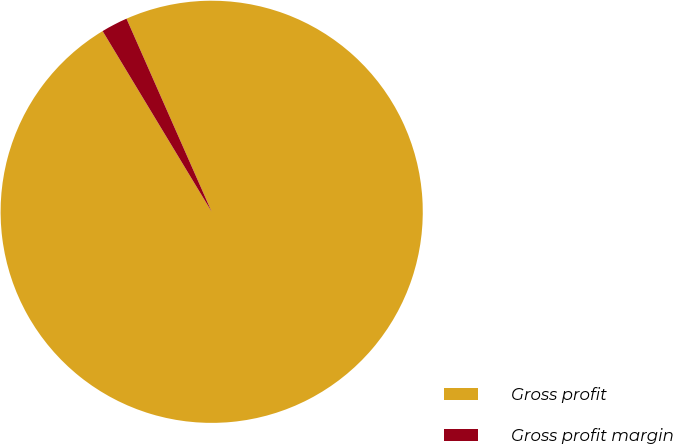Convert chart to OTSL. <chart><loc_0><loc_0><loc_500><loc_500><pie_chart><fcel>Gross profit<fcel>Gross profit margin<nl><fcel>97.97%<fcel>2.03%<nl></chart> 